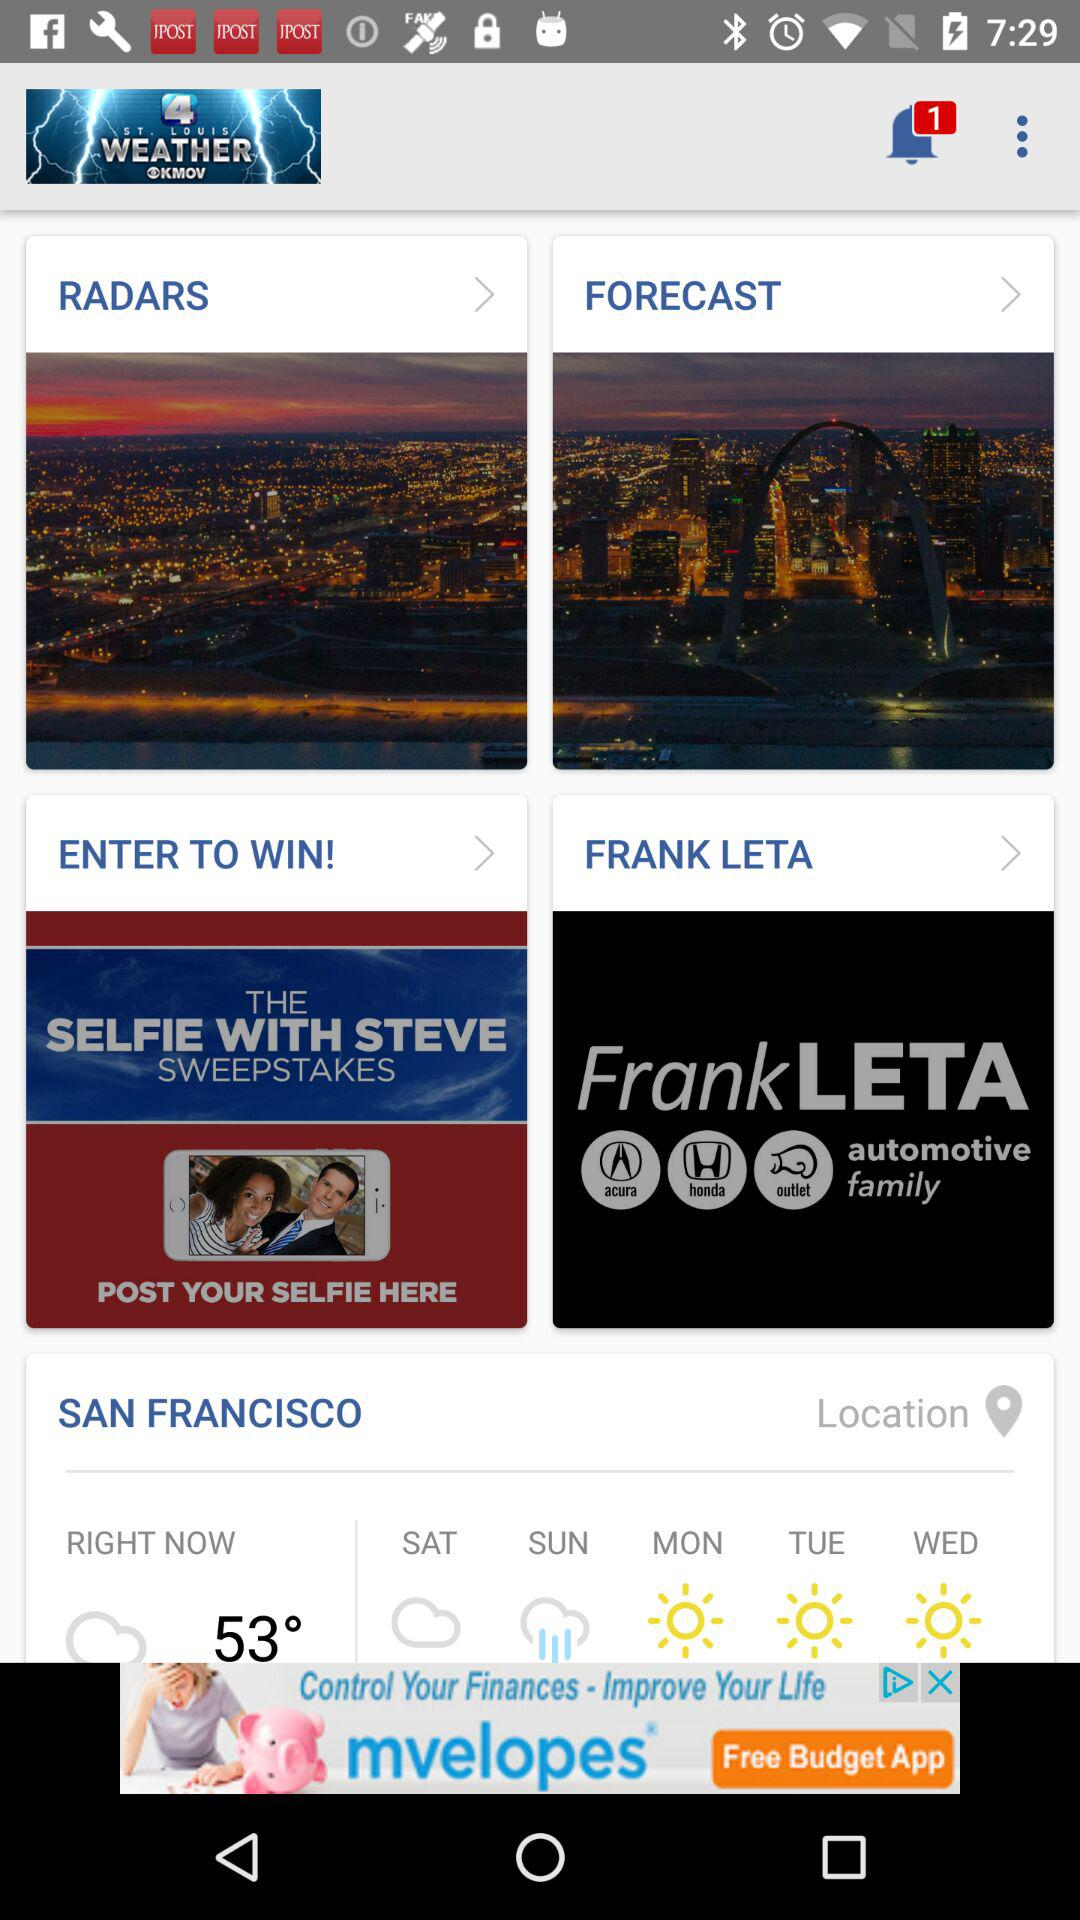What is the temperature? The temperature is 53 degrees. 